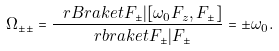Convert formula to latex. <formula><loc_0><loc_0><loc_500><loc_500>\Omega _ { \pm \pm } = \frac { \ r B r a k e t { F _ { \pm } | [ \omega _ { 0 } F _ { z } , F _ { \pm } ] } } { \ r b r a k e t { F _ { \pm } | F _ { \pm } } } = \pm \omega _ { 0 } .</formula> 